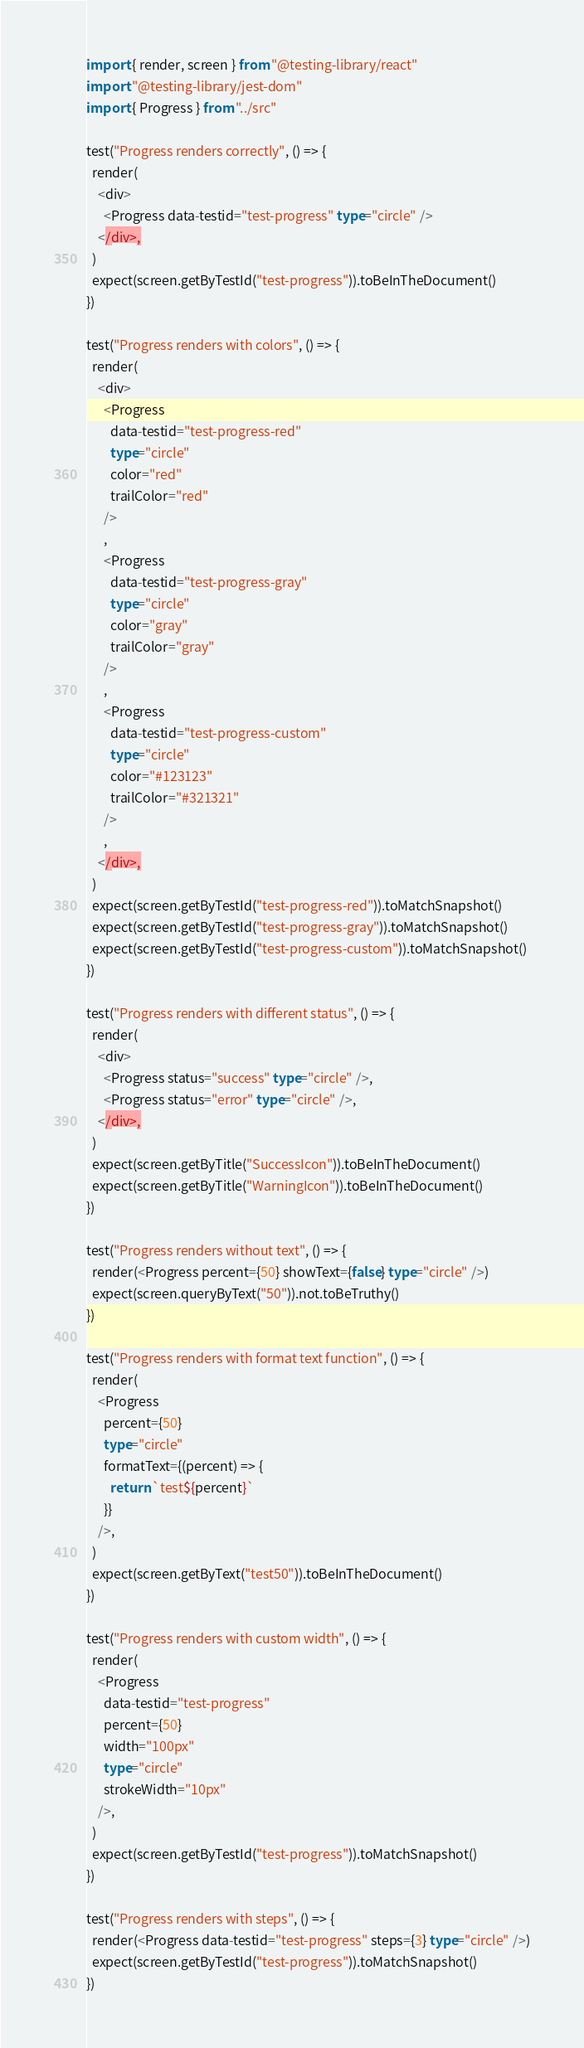<code> <loc_0><loc_0><loc_500><loc_500><_TypeScript_>import { render, screen } from "@testing-library/react"
import "@testing-library/jest-dom"
import { Progress } from "../src"

test("Progress renders correctly", () => {
  render(
    <div>
      <Progress data-testid="test-progress" type="circle" />
    </div>,
  )
  expect(screen.getByTestId("test-progress")).toBeInTheDocument()
})

test("Progress renders with colors", () => {
  render(
    <div>
      <Progress
        data-testid="test-progress-red"
        type="circle"
        color="red"
        trailColor="red"
      />
      ,
      <Progress
        data-testid="test-progress-gray"
        type="circle"
        color="gray"
        trailColor="gray"
      />
      ,
      <Progress
        data-testid="test-progress-custom"
        type="circle"
        color="#123123"
        trailColor="#321321"
      />
      ,
    </div>,
  )
  expect(screen.getByTestId("test-progress-red")).toMatchSnapshot()
  expect(screen.getByTestId("test-progress-gray")).toMatchSnapshot()
  expect(screen.getByTestId("test-progress-custom")).toMatchSnapshot()
})

test("Progress renders with different status", () => {
  render(
    <div>
      <Progress status="success" type="circle" />,
      <Progress status="error" type="circle" />,
    </div>,
  )
  expect(screen.getByTitle("SuccessIcon")).toBeInTheDocument()
  expect(screen.getByTitle("WarningIcon")).toBeInTheDocument()
})

test("Progress renders without text", () => {
  render(<Progress percent={50} showText={false} type="circle" />)
  expect(screen.queryByText("50")).not.toBeTruthy()
})

test("Progress renders with format text function", () => {
  render(
    <Progress
      percent={50}
      type="circle"
      formatText={(percent) => {
        return `test${percent}`
      }}
    />,
  )
  expect(screen.getByText("test50")).toBeInTheDocument()
})

test("Progress renders with custom width", () => {
  render(
    <Progress
      data-testid="test-progress"
      percent={50}
      width="100px"
      type="circle"
      strokeWidth="10px"
    />,
  )
  expect(screen.getByTestId("test-progress")).toMatchSnapshot()
})

test("Progress renders with steps", () => {
  render(<Progress data-testid="test-progress" steps={3} type="circle" />)
  expect(screen.getByTestId("test-progress")).toMatchSnapshot()
})
</code> 